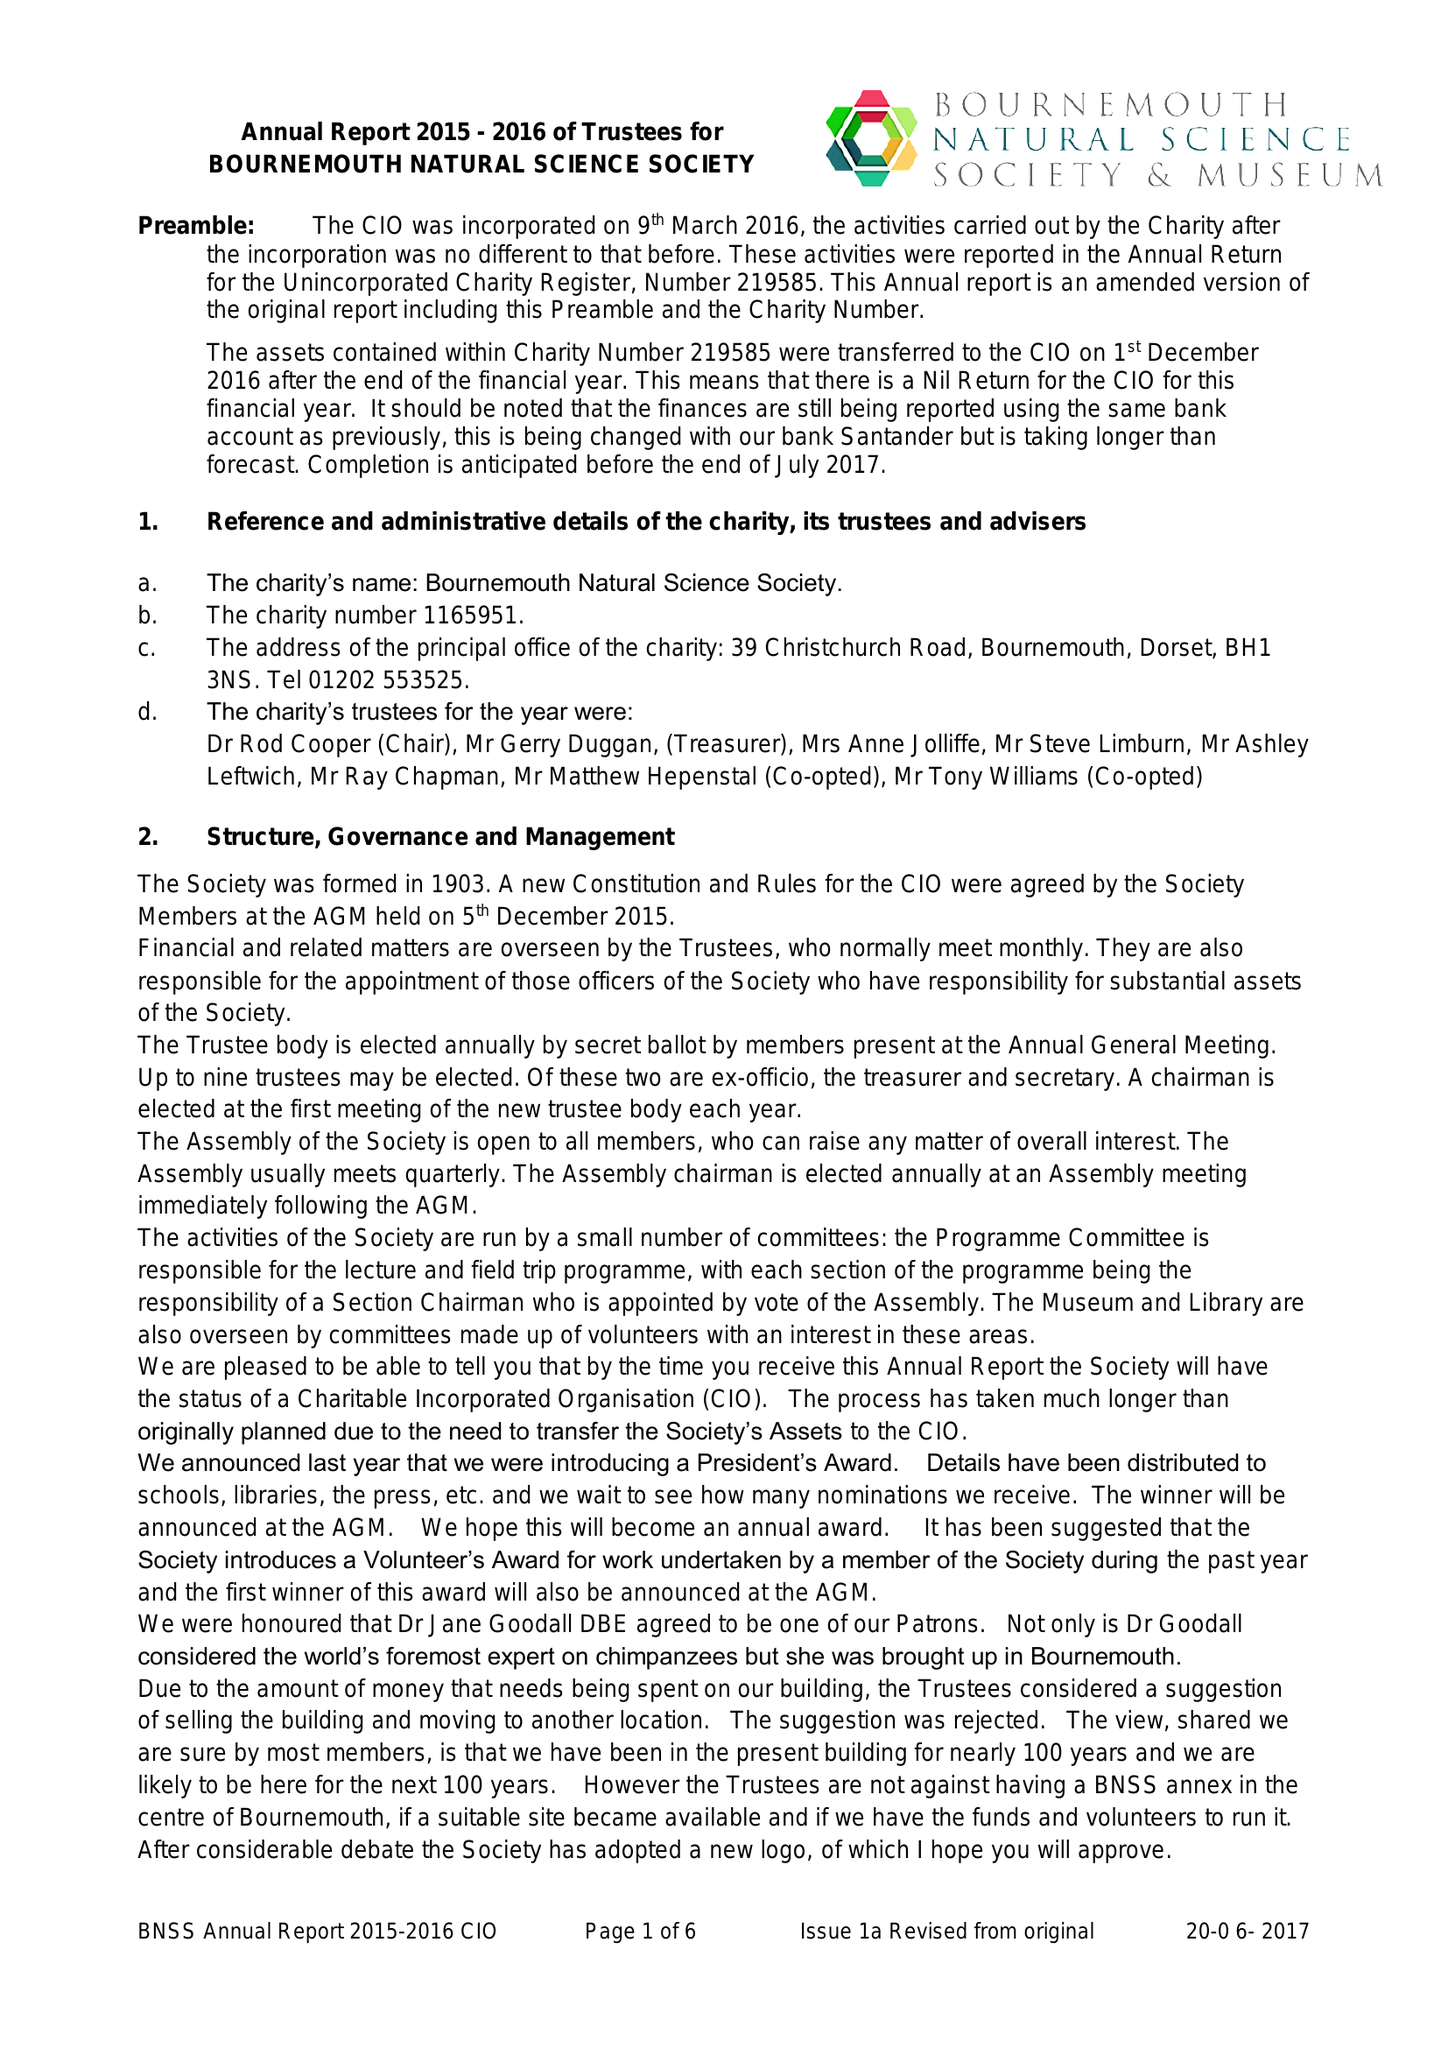What is the value for the charity_name?
Answer the question using a single word or phrase. Bournemouth Natural Science Society 